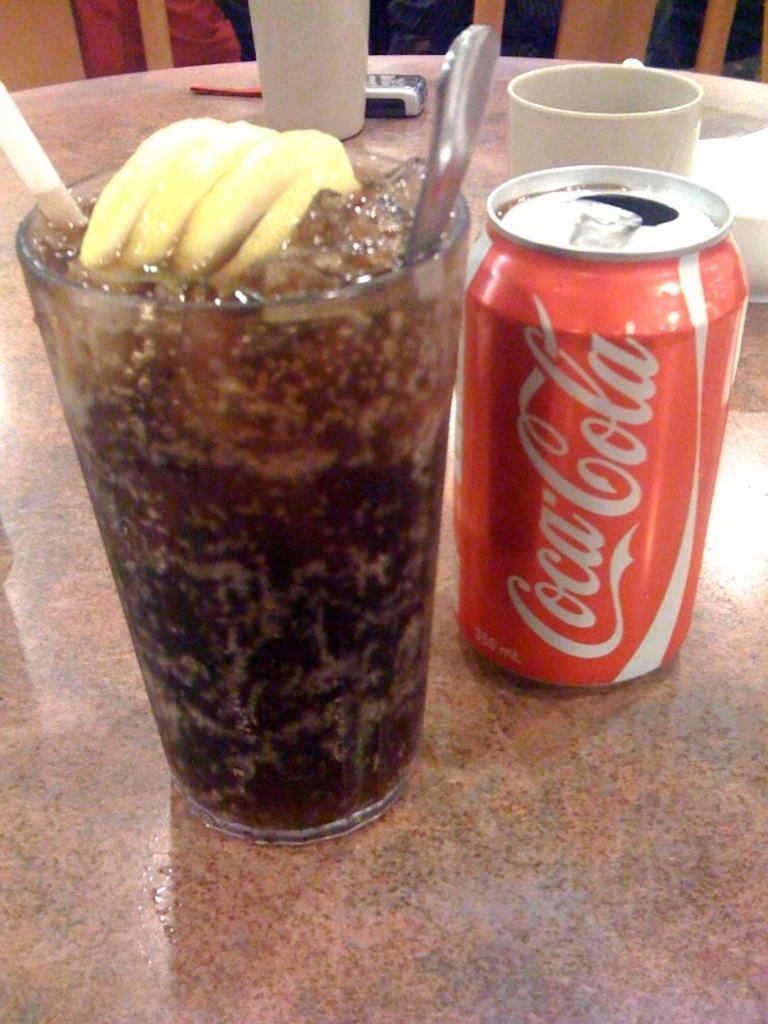Describe this image in one or two sentences. As we can see in the image there is a table. On table there is a glass, mobile phone, cup and a tin. 